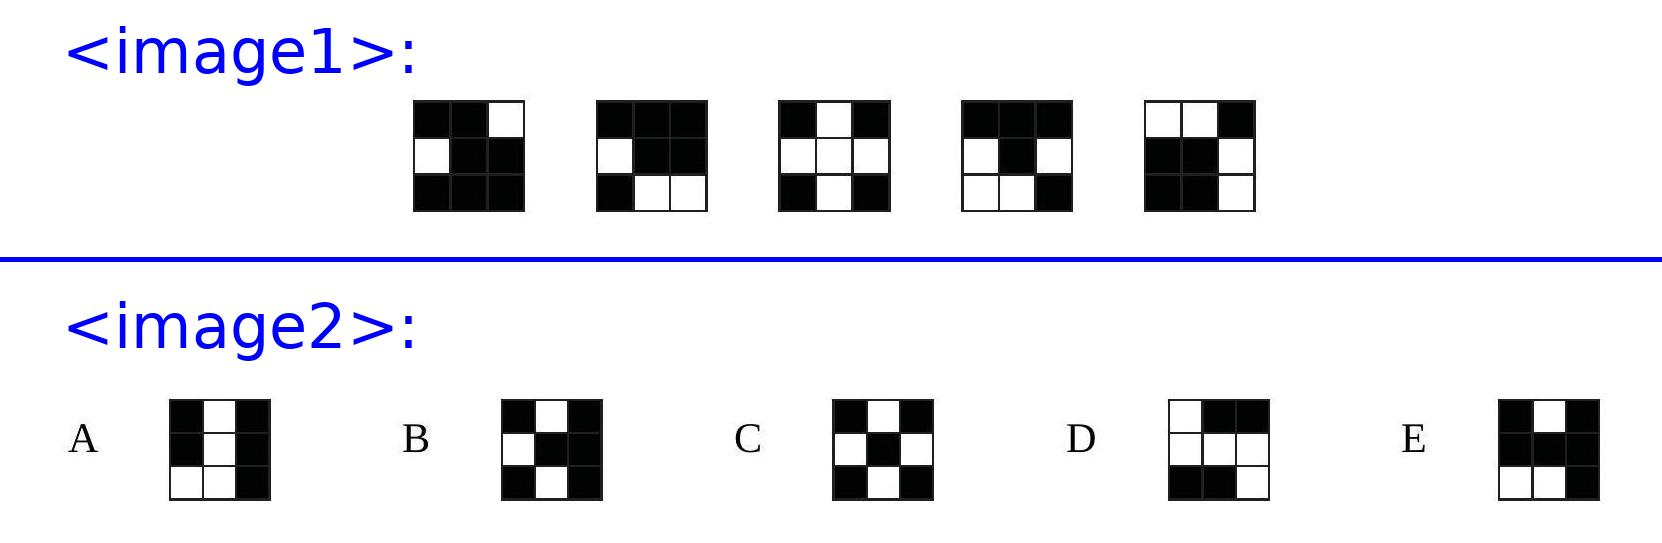Can we use the visible patterns to speculate on the placement of individual cubes within the overall 3D structure? Absolutely. The placement of black and white cubes in the visible patterns provides clues about their relational adjacency in the 3D structure of the cube. Analyzing symmetry and reoccurrence can help us hypothesize about the likely positions of similarly colored cubes in the adjacent yet unseen sixth face. 